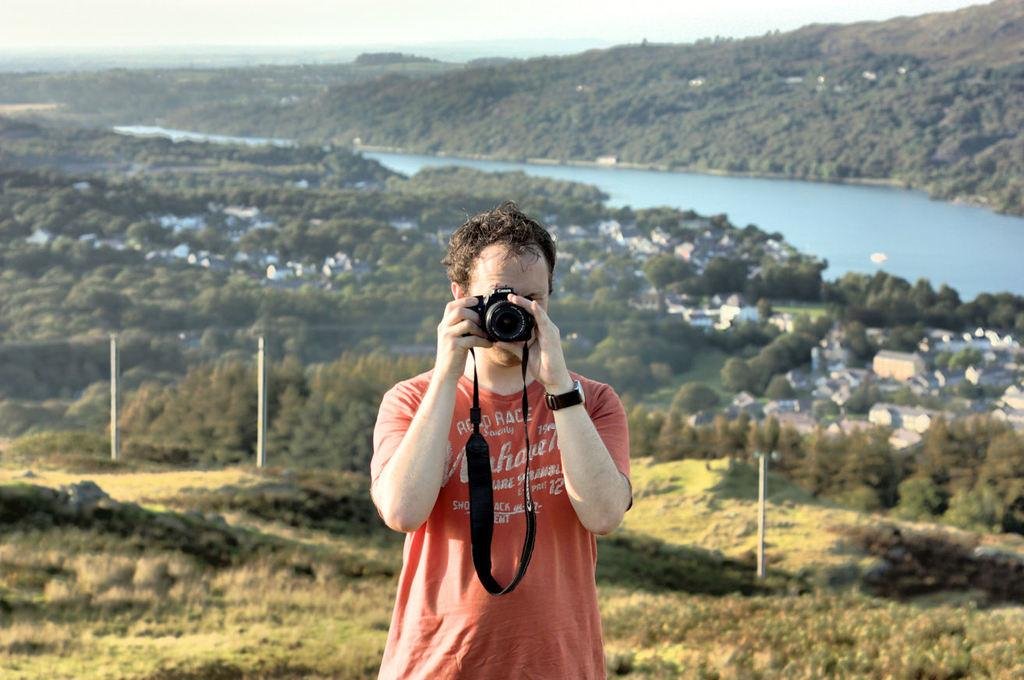What is the main subject of the image? There is a man standing in the center of the image. What is the man holding in his hand? The man is holding a camera in his hand. What can be seen in the background of the image? There are hills, watersheds, and poles in the background of the image. What is visible at the top of the image? The sky is visible at the top of the image. How many brothers can be seen in the image? There are no brothers present in the image; it features a man holding a camera. What type of root is growing from the camera in the image? There is no root growing from the camera in the image; it is a camera held by a man. 